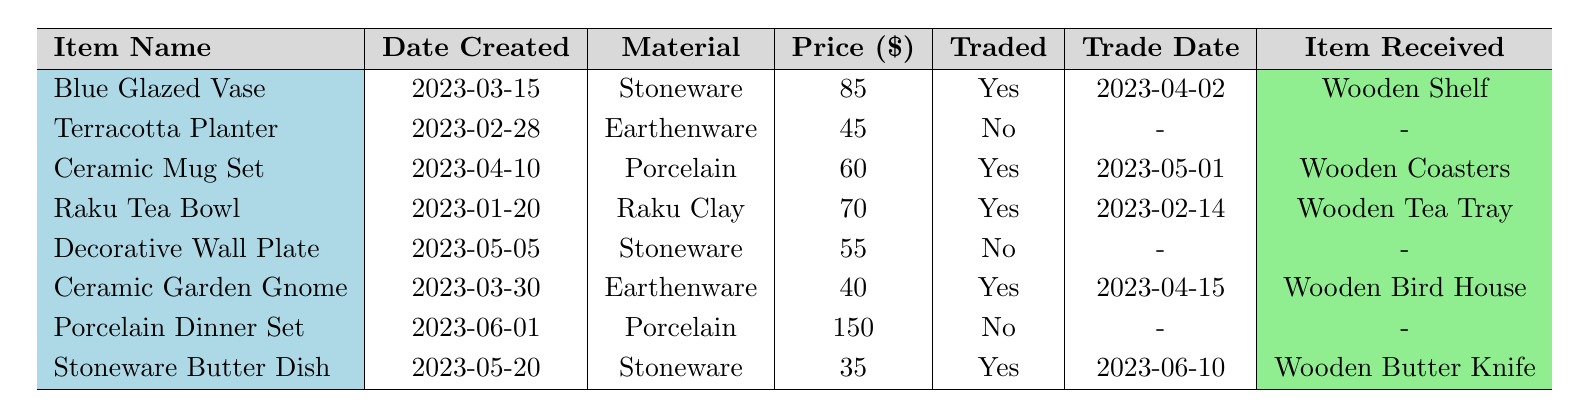What is the price of the Blue Glazed Vase? The price of the Blue Glazed Vase, which is listed in the table, is 85.
Answer: 85 How many pottery items were traded with the carpenter? In the table, there are four items marked as traded with the carpenter, indicated by "Yes" in the traded column.
Answer: 4 What material is the Ceramic Mug Set made of? The table shows that the Ceramic Mug Set is made of Porcelain, as indicated in the material column.
Answer: Porcelain What item was received in trade for the Raku Tea Bowl? The table specifies that in exchange for the Raku Tea Bowl, a Wooden Tea Tray was received, as shown in the item received column.
Answer: Wooden Tea Tray Is there any item listed that was neither traded nor received? Yes, the Terracotta Planter and the Decorative Wall Plate are both listed as not traded, which is shown by "No" in the traded column and no associated item received.
Answer: Yes What is the total price of all traded items? To find the total price of all traded items, we add the prices: 85 (Blue Glazed Vase) + 60 (Ceramic Mug Set) + 40 (Ceramic Garden Gnome) + 35 (Stoneware Butter Dish) = 220.
Answer: 220 What percentage of the items in the inventory have been traded? There are 8 items total, out of which 4 were traded. The percentage is calculated as (4 traded items / 8 total items) * 100 = 50%.
Answer: 50% Which is the most expensive item listed? The Porcelain Dinner Set is the most expensive item, priced at 150, as indicated in the price column.
Answer: Porcelain Dinner Set What was the date of the last trade recorded in the table? The last trade recorded is for the Stoneware Butter Dish, which occurred on June 10, 2023, as shown in the trade date column.
Answer: 2023-06-10 How many items were created after March 1, 2023? Counting the items created after March 1, we see five items: Blue Glazed Vase, Ceramic Mug Set, Decorative Wall Plate, Ceramic Garden Gnome, and Stoneware Butter Dish.
Answer: 5 